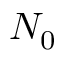<formula> <loc_0><loc_0><loc_500><loc_500>N _ { 0 }</formula> 